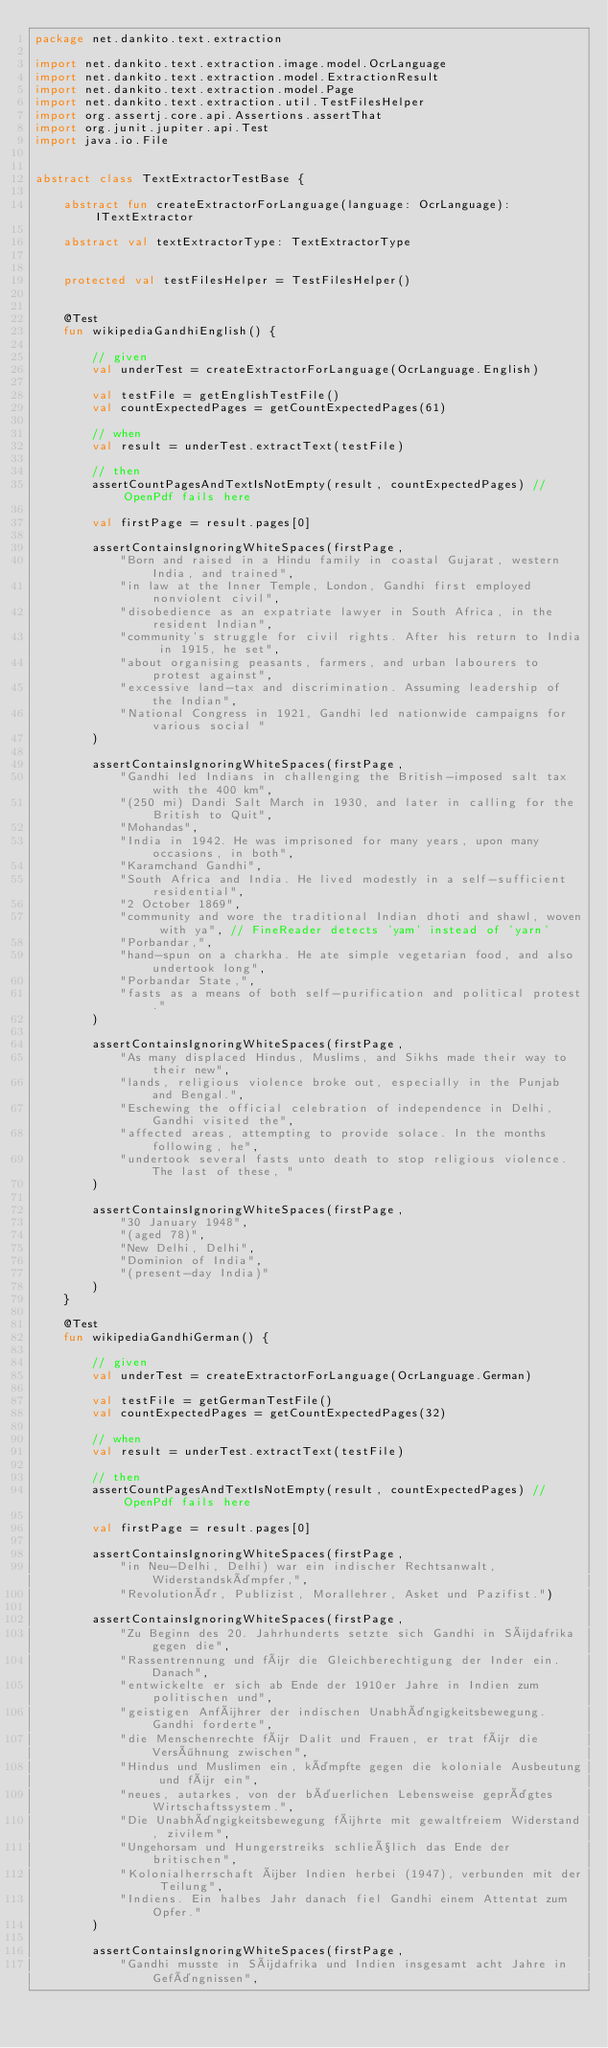<code> <loc_0><loc_0><loc_500><loc_500><_Kotlin_>package net.dankito.text.extraction

import net.dankito.text.extraction.image.model.OcrLanguage
import net.dankito.text.extraction.model.ExtractionResult
import net.dankito.text.extraction.model.Page
import net.dankito.text.extraction.util.TestFilesHelper
import org.assertj.core.api.Assertions.assertThat
import org.junit.jupiter.api.Test
import java.io.File


abstract class TextExtractorTestBase {

    abstract fun createExtractorForLanguage(language: OcrLanguage): ITextExtractor

    abstract val textExtractorType: TextExtractorType


    protected val testFilesHelper = TestFilesHelper()


    @Test
    fun wikipediaGandhiEnglish() {

        // given
        val underTest = createExtractorForLanguage(OcrLanguage.English)

        val testFile = getEnglishTestFile()
        val countExpectedPages = getCountExpectedPages(61)

        // when
        val result = underTest.extractText(testFile)

        // then
        assertCountPagesAndTextIsNotEmpty(result, countExpectedPages) // OpenPdf fails here

        val firstPage = result.pages[0]

        assertContainsIgnoringWhiteSpaces(firstPage,
            "Born and raised in a Hindu family in coastal Gujarat, western India, and trained",
            "in law at the Inner Temple, London, Gandhi first employed nonviolent civil",
            "disobedience as an expatriate lawyer in South Africa, in the resident Indian",
            "community's struggle for civil rights. After his return to India in 1915, he set",
            "about organising peasants, farmers, and urban labourers to protest against",
            "excessive land-tax and discrimination. Assuming leadership of the Indian",
            "National Congress in 1921, Gandhi led nationwide campaigns for various social "
        )

        assertContainsIgnoringWhiteSpaces(firstPage,
            "Gandhi led Indians in challenging the British-imposed salt tax with the 400 km",
            "(250 mi) Dandi Salt March in 1930, and later in calling for the British to Quit",
            "Mohandas",
            "India in 1942. He was imprisoned for many years, upon many occasions, in both",
            "Karamchand Gandhi",
            "South Africa and India. He lived modestly in a self-sufficient residential",
            "2 October 1869",
            "community and wore the traditional Indian dhoti and shawl, woven with ya", // FineReader detects 'yam' instead of 'yarn'
            "Porbandar,",
            "hand-spun on a charkha. He ate simple vegetarian food, and also undertook long",
            "Porbandar State,",
            "fasts as a means of both self-purification and political protest."
        )

        assertContainsIgnoringWhiteSpaces(firstPage,
            "As many displaced Hindus, Muslims, and Sikhs made their way to their new",
            "lands, religious violence broke out, especially in the Punjab and Bengal.",
            "Eschewing the official celebration of independence in Delhi, Gandhi visited the",
            "affected areas, attempting to provide solace. In the months following, he",
            "undertook several fasts unto death to stop religious violence. The last of these, "
        )

        assertContainsIgnoringWhiteSpaces(firstPage,
            "30 January 1948",
            "(aged 78)",
            "New Delhi, Delhi",
            "Dominion of India",
            "(present-day India)"
        )
    }

    @Test
    fun wikipediaGandhiGerman() {

        // given
        val underTest = createExtractorForLanguage(OcrLanguage.German)

        val testFile = getGermanTestFile()
        val countExpectedPages = getCountExpectedPages(32)

        // when
        val result = underTest.extractText(testFile)

        // then
        assertCountPagesAndTextIsNotEmpty(result, countExpectedPages) // OpenPdf fails here

        val firstPage = result.pages[0]

        assertContainsIgnoringWhiteSpaces(firstPage,
            "in Neu-Delhi, Delhi) war ein indischer Rechtsanwalt, Widerstandskämpfer,",
            "Revolutionär, Publizist, Morallehrer, Asket und Pazifist.")

        assertContainsIgnoringWhiteSpaces(firstPage,
            "Zu Beginn des 20. Jahrhunderts setzte sich Gandhi in Südafrika gegen die",
            "Rassentrennung und für die Gleichberechtigung der Inder ein. Danach",
            "entwickelte er sich ab Ende der 1910er Jahre in Indien zum politischen und",
            "geistigen Anführer der indischen Unabhängigkeitsbewegung. Gandhi forderte",
            "die Menschenrechte für Dalit und Frauen, er trat für die Versöhnung zwischen",
            "Hindus und Muslimen ein, kämpfte gegen die koloniale Ausbeutung und für ein",
            "neues, autarkes, von der bäuerlichen Lebensweise geprägtes Wirtschaftssystem.",
            "Die Unabhängigkeitsbewegung führte mit gewaltfreiem Widerstand, zivilem",
            "Ungehorsam und Hungerstreiks schließlich das Ende der britischen",
            "Kolonialherrschaft über Indien herbei (1947), verbunden mit der Teilung",
            "Indiens. Ein halbes Jahr danach fiel Gandhi einem Attentat zum Opfer."
        )

        assertContainsIgnoringWhiteSpaces(firstPage,
            "Gandhi musste in Südafrika und Indien insgesamt acht Jahre in Gefängnissen",</code> 